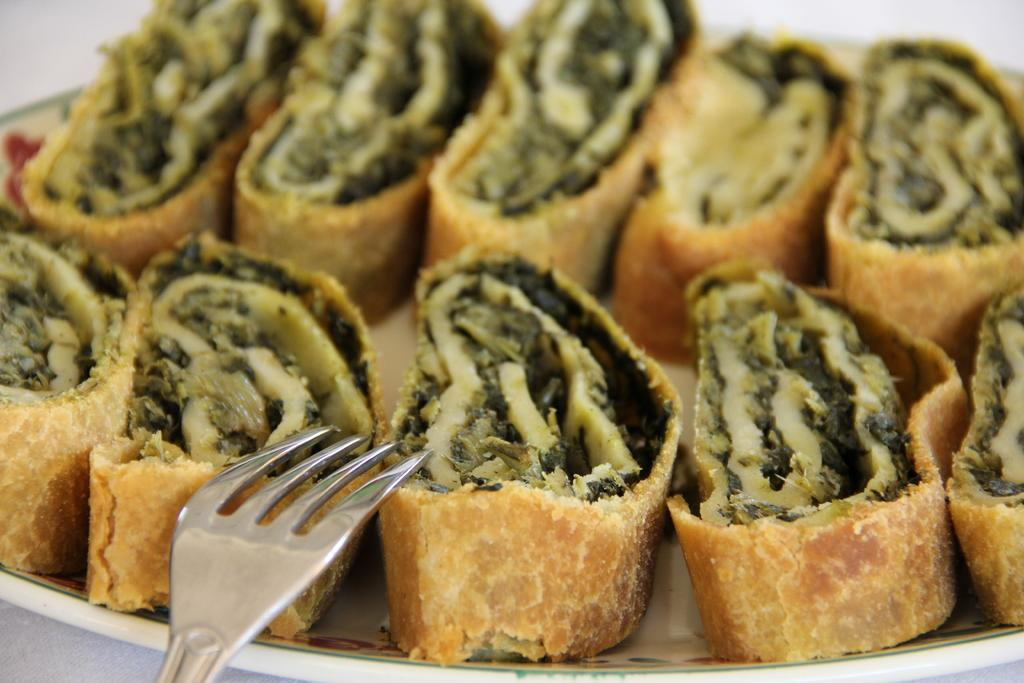What is placed on a surface in the image? There is a plate on a surface in the image. What is located near the plate? There is a fork near the plate. What can be found on the plate? There are food items on the plate. What type of underwear is visible under the plate in the image? There is no underwear visible under the plate in the image. 